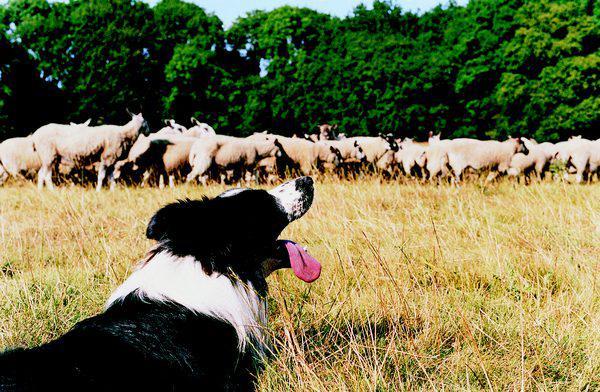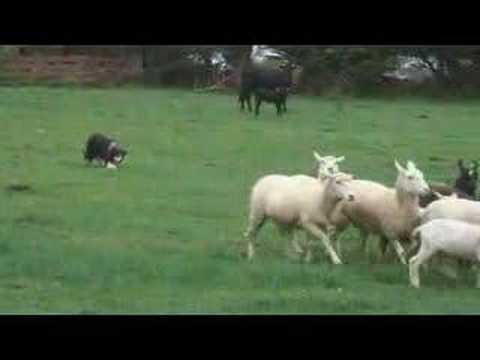The first image is the image on the left, the second image is the image on the right. Analyze the images presented: Is the assertion "In one of the images, there are exactly three sheep." valid? Answer yes or no. No. The first image is the image on the left, the second image is the image on the right. Examine the images to the left and right. Is the description "A dog is positioned closest to the front of an image, with multiple sheep in the back." accurate? Answer yes or no. Yes. 